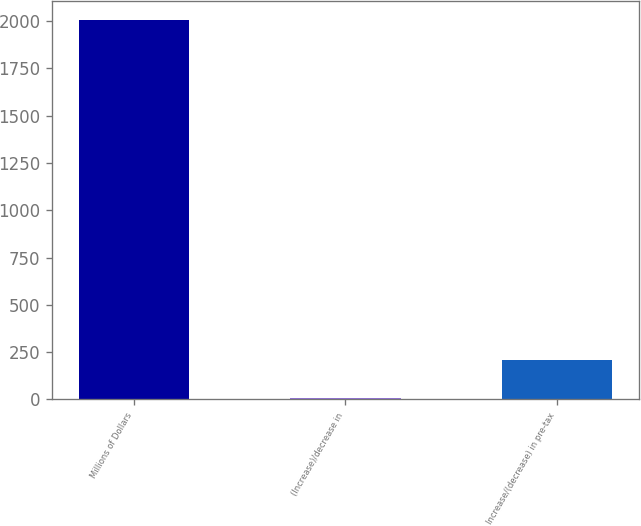Convert chart to OTSL. <chart><loc_0><loc_0><loc_500><loc_500><bar_chart><fcel>Millions of Dollars<fcel>(Increase)/decrease in<fcel>Increase/(decrease) in pre-tax<nl><fcel>2007<fcel>8<fcel>207.9<nl></chart> 